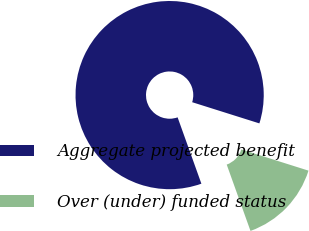<chart> <loc_0><loc_0><loc_500><loc_500><pie_chart><fcel>Aggregate projected benefit<fcel>Over (under) funded status<nl><fcel>85.34%<fcel>14.66%<nl></chart> 